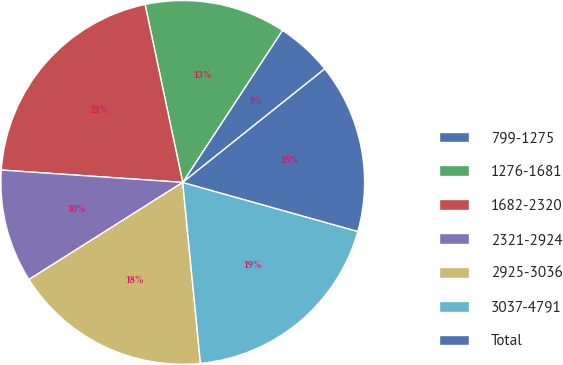Convert chart. <chart><loc_0><loc_0><loc_500><loc_500><pie_chart><fcel>799-1275<fcel>1276-1681<fcel>1682-2320<fcel>2321-2924<fcel>2925-3036<fcel>3037-4791<fcel>Total<nl><fcel>5.03%<fcel>12.56%<fcel>20.6%<fcel>10.05%<fcel>17.59%<fcel>19.1%<fcel>15.08%<nl></chart> 